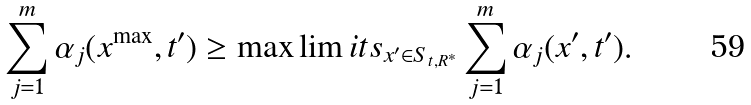<formula> <loc_0><loc_0><loc_500><loc_500>\sum _ { j = 1 } ^ { m } \alpha _ { j } ( x ^ { \max } , t ^ { \prime } ) \geq \max \lim i t s _ { x ^ { \prime } \in S _ { t , R ^ { * } } } \sum _ { j = 1 } ^ { m } \alpha _ { j } ( x ^ { \prime } , t ^ { \prime } ) .</formula> 